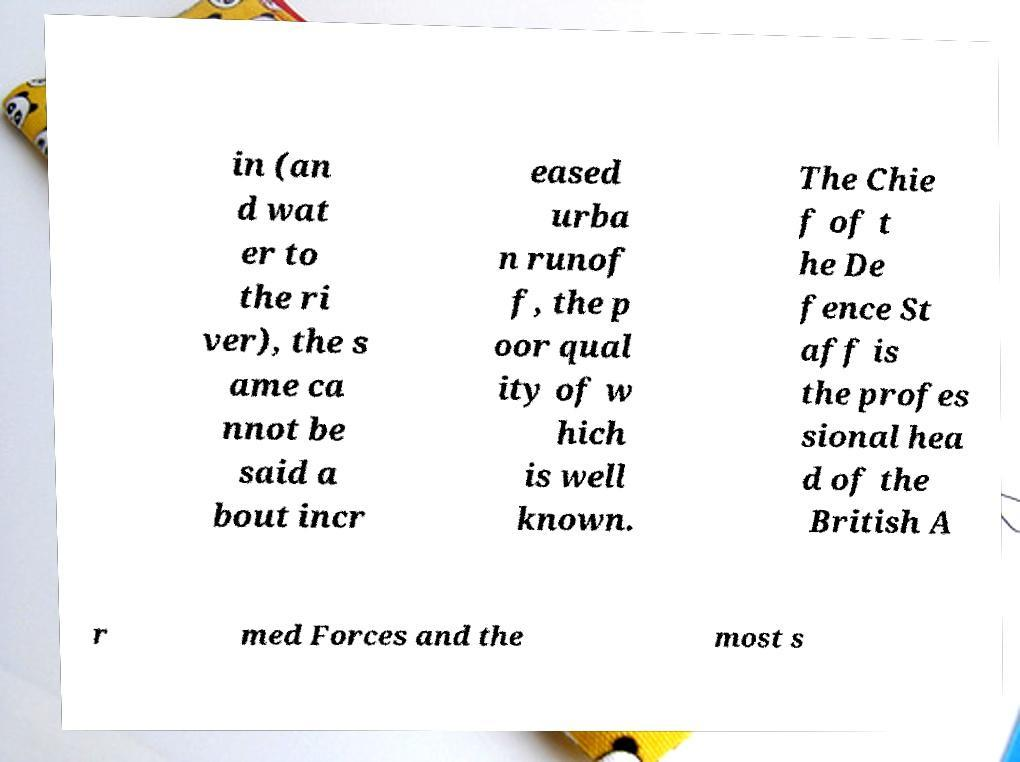What messages or text are displayed in this image? I need them in a readable, typed format. in (an d wat er to the ri ver), the s ame ca nnot be said a bout incr eased urba n runof f, the p oor qual ity of w hich is well known. The Chie f of t he De fence St aff is the profes sional hea d of the British A r med Forces and the most s 